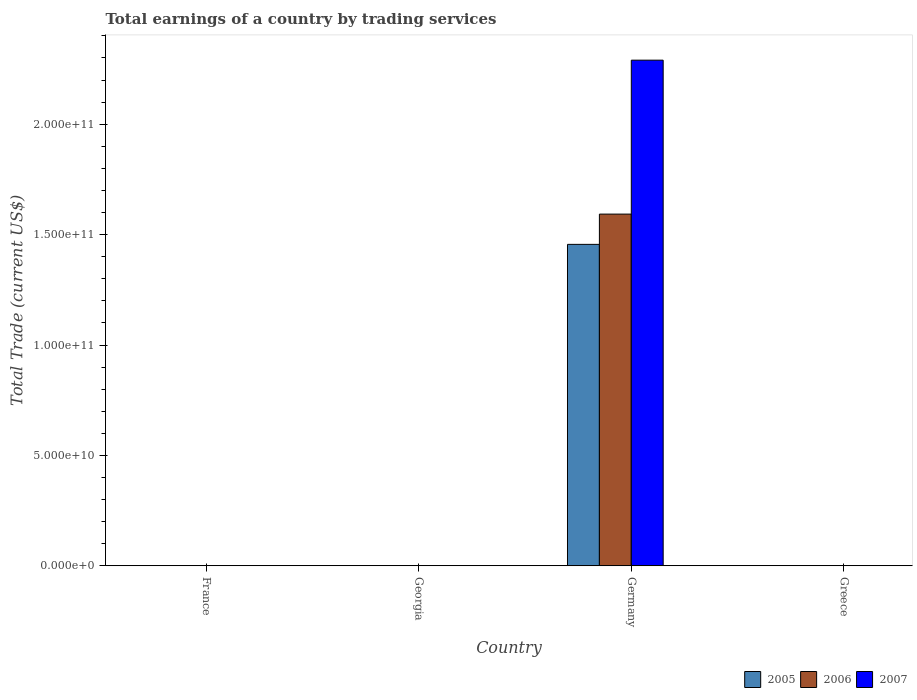How many different coloured bars are there?
Provide a succinct answer. 3. Are the number of bars per tick equal to the number of legend labels?
Provide a succinct answer. No. Are the number of bars on each tick of the X-axis equal?
Your answer should be very brief. No. How many bars are there on the 3rd tick from the right?
Offer a terse response. 0. What is the label of the 2nd group of bars from the left?
Offer a terse response. Georgia. Across all countries, what is the maximum total earnings in 2005?
Make the answer very short. 1.46e+11. In which country was the total earnings in 2007 maximum?
Give a very brief answer. Germany. What is the total total earnings in 2005 in the graph?
Make the answer very short. 1.46e+11. What is the average total earnings in 2007 per country?
Provide a short and direct response. 5.73e+1. What is the difference between the total earnings of/in 2007 and total earnings of/in 2005 in Germany?
Your response must be concise. 8.34e+1. What is the difference between the highest and the lowest total earnings in 2006?
Keep it short and to the point. 1.59e+11. In how many countries, is the total earnings in 2007 greater than the average total earnings in 2007 taken over all countries?
Offer a terse response. 1. Are all the bars in the graph horizontal?
Make the answer very short. No. How many countries are there in the graph?
Ensure brevity in your answer.  4. What is the difference between two consecutive major ticks on the Y-axis?
Keep it short and to the point. 5.00e+1. Are the values on the major ticks of Y-axis written in scientific E-notation?
Ensure brevity in your answer.  Yes. Does the graph contain any zero values?
Your answer should be very brief. Yes. Does the graph contain grids?
Offer a terse response. No. Where does the legend appear in the graph?
Provide a short and direct response. Bottom right. What is the title of the graph?
Your answer should be compact. Total earnings of a country by trading services. What is the label or title of the Y-axis?
Offer a terse response. Total Trade (current US$). What is the Total Trade (current US$) of 2005 in France?
Your answer should be compact. 0. What is the Total Trade (current US$) in 2006 in France?
Keep it short and to the point. 0. What is the Total Trade (current US$) of 2007 in France?
Give a very brief answer. 0. What is the Total Trade (current US$) in 2005 in Germany?
Offer a very short reply. 1.46e+11. What is the Total Trade (current US$) in 2006 in Germany?
Your answer should be very brief. 1.59e+11. What is the Total Trade (current US$) of 2007 in Germany?
Ensure brevity in your answer.  2.29e+11. Across all countries, what is the maximum Total Trade (current US$) in 2005?
Provide a short and direct response. 1.46e+11. Across all countries, what is the maximum Total Trade (current US$) of 2006?
Offer a terse response. 1.59e+11. Across all countries, what is the maximum Total Trade (current US$) of 2007?
Make the answer very short. 2.29e+11. Across all countries, what is the minimum Total Trade (current US$) in 2005?
Your answer should be very brief. 0. What is the total Total Trade (current US$) in 2005 in the graph?
Offer a terse response. 1.46e+11. What is the total Total Trade (current US$) in 2006 in the graph?
Your answer should be compact. 1.59e+11. What is the total Total Trade (current US$) of 2007 in the graph?
Make the answer very short. 2.29e+11. What is the average Total Trade (current US$) in 2005 per country?
Provide a short and direct response. 3.64e+1. What is the average Total Trade (current US$) of 2006 per country?
Your answer should be very brief. 3.98e+1. What is the average Total Trade (current US$) in 2007 per country?
Your response must be concise. 5.73e+1. What is the difference between the Total Trade (current US$) in 2005 and Total Trade (current US$) in 2006 in Germany?
Your response must be concise. -1.37e+1. What is the difference between the Total Trade (current US$) of 2005 and Total Trade (current US$) of 2007 in Germany?
Provide a short and direct response. -8.34e+1. What is the difference between the Total Trade (current US$) of 2006 and Total Trade (current US$) of 2007 in Germany?
Keep it short and to the point. -6.97e+1. What is the difference between the highest and the lowest Total Trade (current US$) in 2005?
Your answer should be compact. 1.46e+11. What is the difference between the highest and the lowest Total Trade (current US$) of 2006?
Make the answer very short. 1.59e+11. What is the difference between the highest and the lowest Total Trade (current US$) of 2007?
Your answer should be compact. 2.29e+11. 